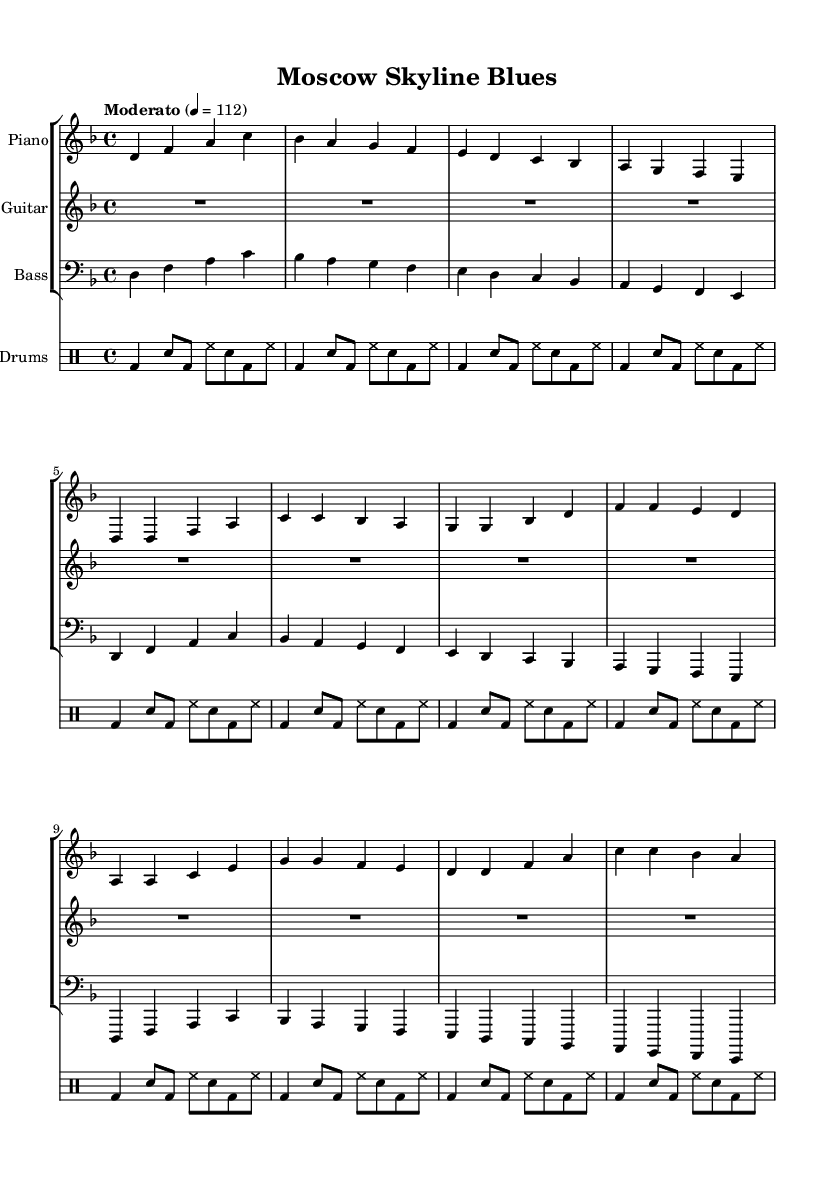What is the key signature of this music? The key signature is indicated at the beginning of the score and shows two flats, which corresponds to the key of D minor.
Answer: D minor What is the time signature of this music? The time signature is shown at the beginning of the score and is written as 4/4, indicating four beats per measure.
Answer: 4/4 What tempo marking is used in this piece? The tempo is indicated in the score with the word "Moderato" and a metronome mark of 112 beats per minute.
Answer: Moderato How many measures are in the verse section? The verse section is comprised of two lines of music, each containing four measures, totaling eight measures.
Answer: 8 Which instrument has rests in the intro section? The guitar part shows a whole rest in the intro section, indicating that it does not play during this time.
Answer: Guitar In which musical section does the chorus begin? The chorus of the piece starts after the verse and is marked by the transition into a new pattern of notes in the score.
Answer: After the verse What type of influences are incorporated into this jazz-rock fusion piece? The title "Moscow Skyline Blues" and the incorporation of folk elements suggest that Russian folk influences are present in this jazz-rock fusion.
Answer: Russian folk influences 